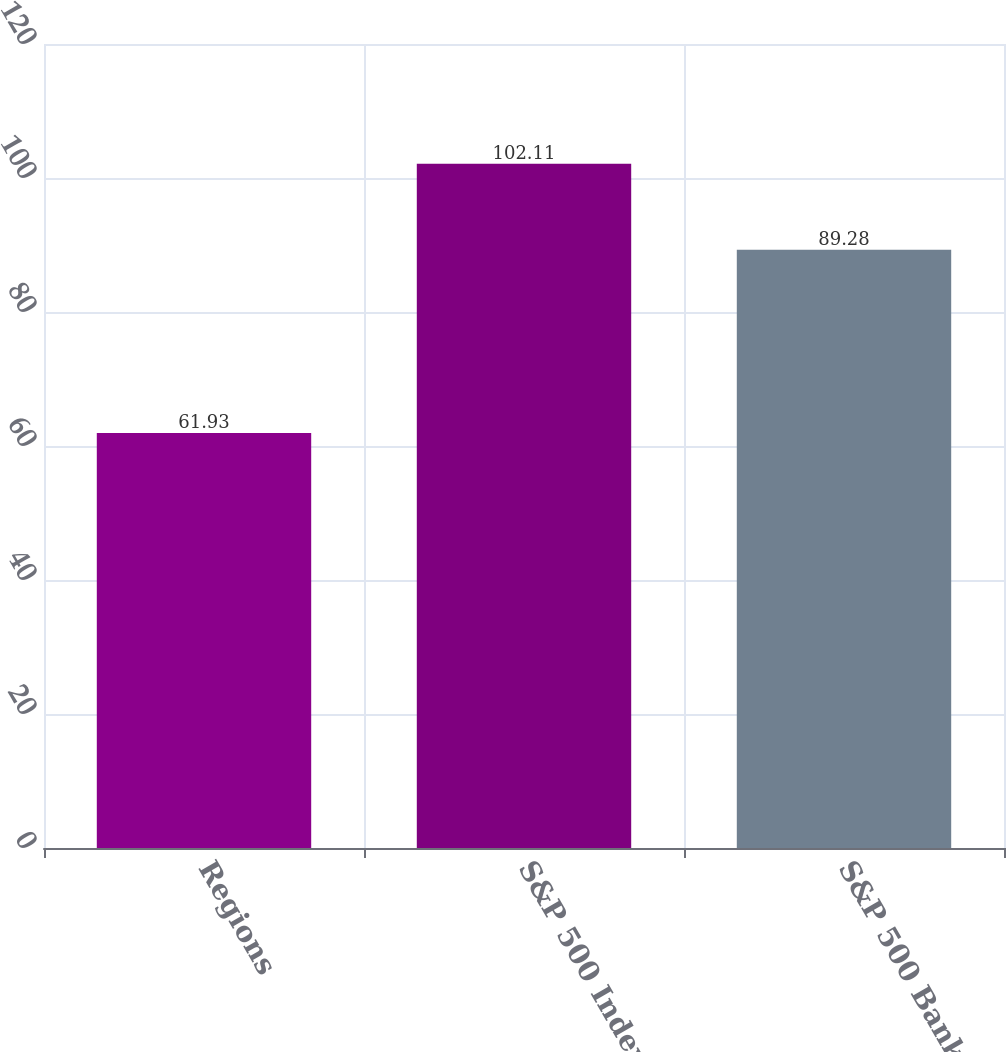Convert chart. <chart><loc_0><loc_0><loc_500><loc_500><bar_chart><fcel>Regions<fcel>S&P 500 Index<fcel>S&P 500 Banks Index<nl><fcel>61.93<fcel>102.11<fcel>89.28<nl></chart> 